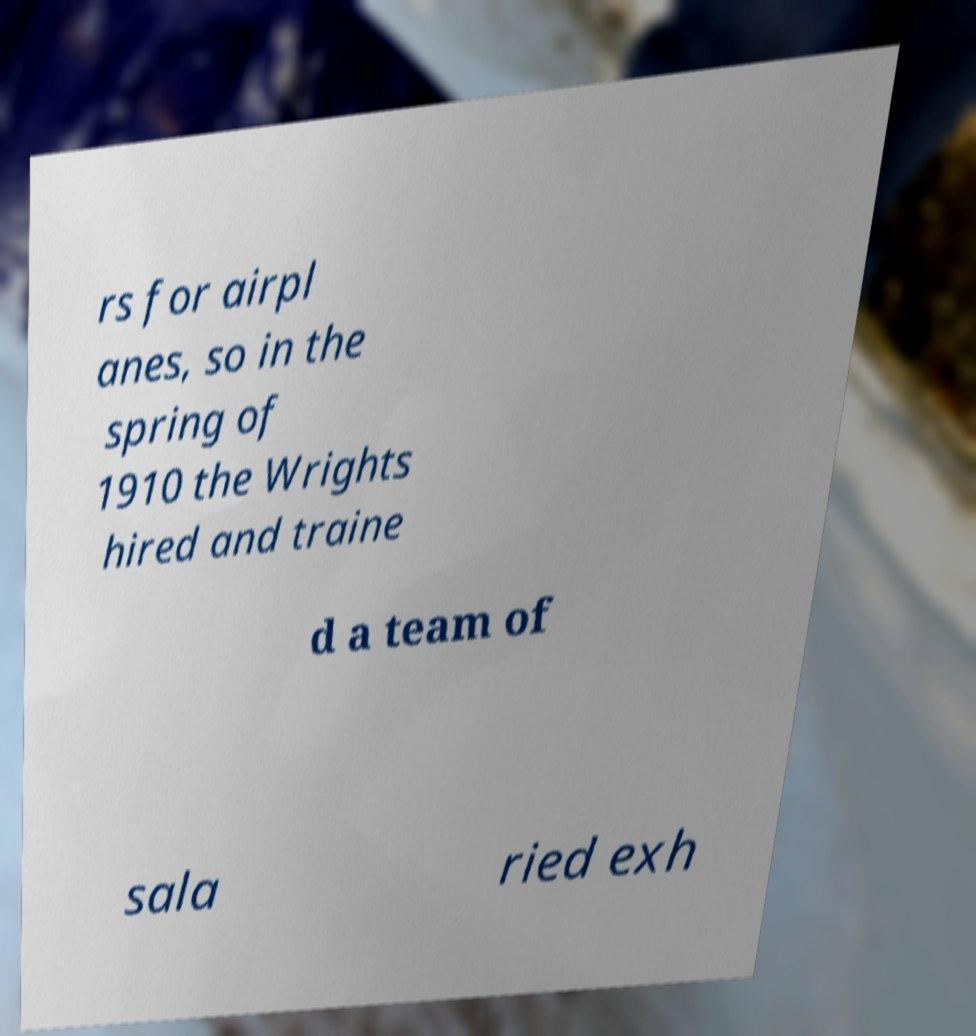Please identify and transcribe the text found in this image. rs for airpl anes, so in the spring of 1910 the Wrights hired and traine d a team of sala ried exh 